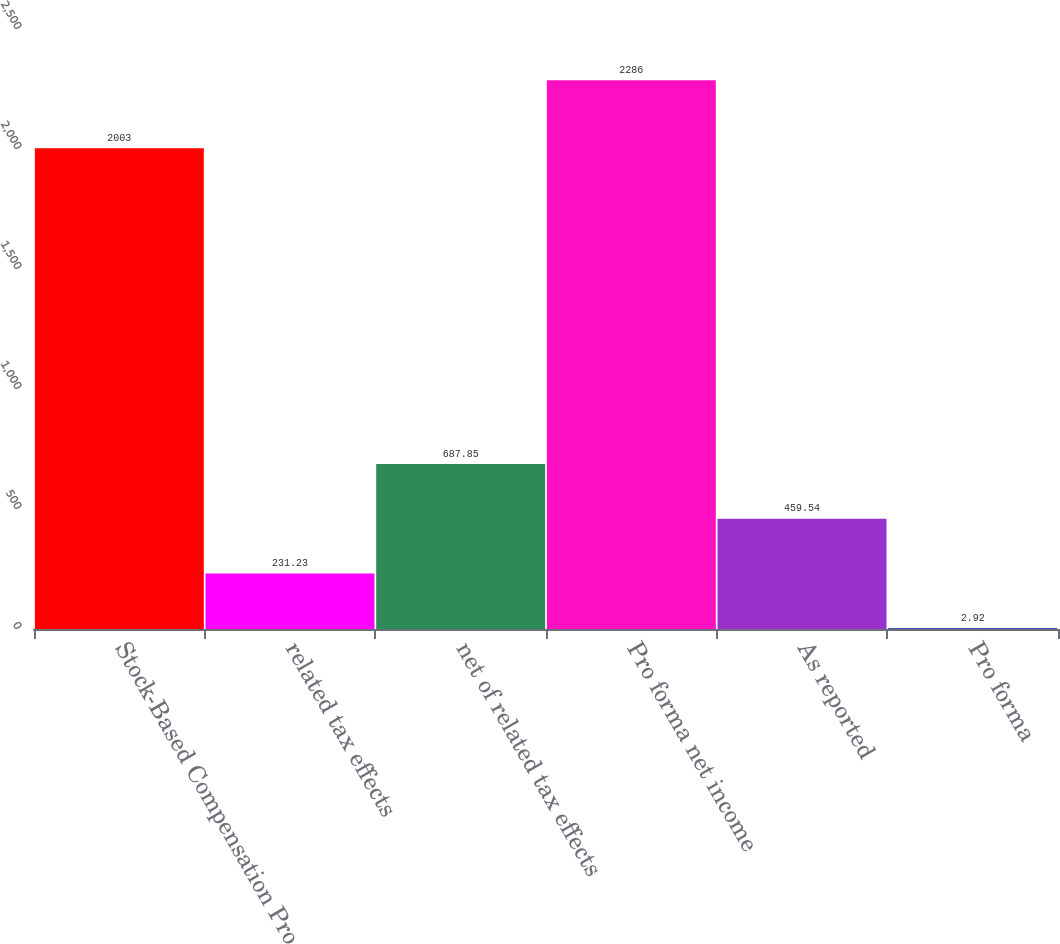Convert chart. <chart><loc_0><loc_0><loc_500><loc_500><bar_chart><fcel>Stock-Based Compensation Pro<fcel>related tax effects<fcel>net of related tax effects<fcel>Pro forma net income<fcel>As reported<fcel>Pro forma<nl><fcel>2003<fcel>231.23<fcel>687.85<fcel>2286<fcel>459.54<fcel>2.92<nl></chart> 